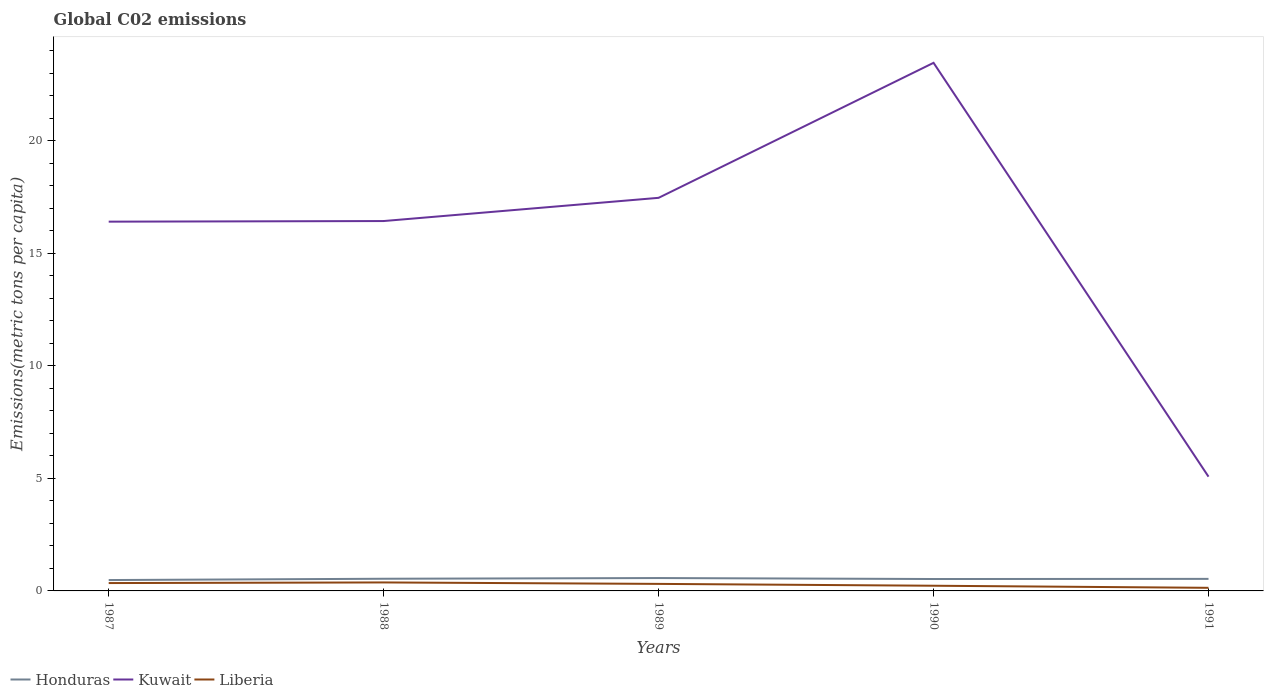How many different coloured lines are there?
Provide a short and direct response. 3. Does the line corresponding to Honduras intersect with the line corresponding to Liberia?
Provide a succinct answer. No. Is the number of lines equal to the number of legend labels?
Keep it short and to the point. Yes. Across all years, what is the maximum amount of CO2 emitted in in Honduras?
Give a very brief answer. 0.48. In which year was the amount of CO2 emitted in in Liberia maximum?
Ensure brevity in your answer.  1991. What is the total amount of CO2 emitted in in Liberia in the graph?
Offer a very short reply. 0.06. What is the difference between the highest and the second highest amount of CO2 emitted in in Liberia?
Offer a very short reply. 0.24. Is the amount of CO2 emitted in in Honduras strictly greater than the amount of CO2 emitted in in Liberia over the years?
Give a very brief answer. No. How many years are there in the graph?
Offer a terse response. 5. What is the difference between two consecutive major ticks on the Y-axis?
Keep it short and to the point. 5. Are the values on the major ticks of Y-axis written in scientific E-notation?
Your response must be concise. No. Does the graph contain grids?
Your answer should be compact. No. What is the title of the graph?
Offer a very short reply. Global C02 emissions. What is the label or title of the Y-axis?
Your answer should be compact. Emissions(metric tons per capita). What is the Emissions(metric tons per capita) of Honduras in 1987?
Give a very brief answer. 0.48. What is the Emissions(metric tons per capita) of Kuwait in 1987?
Your answer should be very brief. 16.41. What is the Emissions(metric tons per capita) of Liberia in 1987?
Provide a short and direct response. 0.35. What is the Emissions(metric tons per capita) in Honduras in 1988?
Offer a very short reply. 0.54. What is the Emissions(metric tons per capita) in Kuwait in 1988?
Your answer should be compact. 16.44. What is the Emissions(metric tons per capita) in Liberia in 1988?
Ensure brevity in your answer.  0.38. What is the Emissions(metric tons per capita) in Honduras in 1989?
Your answer should be compact. 0.57. What is the Emissions(metric tons per capita) in Kuwait in 1989?
Ensure brevity in your answer.  17.47. What is the Emissions(metric tons per capita) of Liberia in 1989?
Provide a short and direct response. 0.31. What is the Emissions(metric tons per capita) in Honduras in 1990?
Your response must be concise. 0.53. What is the Emissions(metric tons per capita) in Kuwait in 1990?
Make the answer very short. 23.47. What is the Emissions(metric tons per capita) of Liberia in 1990?
Make the answer very short. 0.23. What is the Emissions(metric tons per capita) in Honduras in 1991?
Provide a short and direct response. 0.54. What is the Emissions(metric tons per capita) of Kuwait in 1991?
Provide a short and direct response. 5.08. What is the Emissions(metric tons per capita) of Liberia in 1991?
Your response must be concise. 0.14. Across all years, what is the maximum Emissions(metric tons per capita) of Honduras?
Keep it short and to the point. 0.57. Across all years, what is the maximum Emissions(metric tons per capita) in Kuwait?
Your answer should be very brief. 23.47. Across all years, what is the maximum Emissions(metric tons per capita) of Liberia?
Your response must be concise. 0.38. Across all years, what is the minimum Emissions(metric tons per capita) of Honduras?
Provide a succinct answer. 0.48. Across all years, what is the minimum Emissions(metric tons per capita) of Kuwait?
Keep it short and to the point. 5.08. Across all years, what is the minimum Emissions(metric tons per capita) of Liberia?
Your answer should be compact. 0.14. What is the total Emissions(metric tons per capita) of Honduras in the graph?
Keep it short and to the point. 2.66. What is the total Emissions(metric tons per capita) in Kuwait in the graph?
Offer a terse response. 78.85. What is the total Emissions(metric tons per capita) of Liberia in the graph?
Your answer should be very brief. 1.41. What is the difference between the Emissions(metric tons per capita) in Honduras in 1987 and that in 1988?
Provide a short and direct response. -0.06. What is the difference between the Emissions(metric tons per capita) in Kuwait in 1987 and that in 1988?
Your answer should be very brief. -0.03. What is the difference between the Emissions(metric tons per capita) in Liberia in 1987 and that in 1988?
Provide a short and direct response. -0.03. What is the difference between the Emissions(metric tons per capita) of Honduras in 1987 and that in 1989?
Your answer should be very brief. -0.09. What is the difference between the Emissions(metric tons per capita) in Kuwait in 1987 and that in 1989?
Provide a short and direct response. -1.06. What is the difference between the Emissions(metric tons per capita) in Liberia in 1987 and that in 1989?
Provide a succinct answer. 0.04. What is the difference between the Emissions(metric tons per capita) of Honduras in 1987 and that in 1990?
Provide a succinct answer. -0.05. What is the difference between the Emissions(metric tons per capita) in Kuwait in 1987 and that in 1990?
Offer a very short reply. -7.06. What is the difference between the Emissions(metric tons per capita) of Liberia in 1987 and that in 1990?
Provide a succinct answer. 0.12. What is the difference between the Emissions(metric tons per capita) in Honduras in 1987 and that in 1991?
Provide a succinct answer. -0.05. What is the difference between the Emissions(metric tons per capita) in Kuwait in 1987 and that in 1991?
Give a very brief answer. 11.33. What is the difference between the Emissions(metric tons per capita) in Liberia in 1987 and that in 1991?
Provide a short and direct response. 0.21. What is the difference between the Emissions(metric tons per capita) in Honduras in 1988 and that in 1989?
Offer a terse response. -0.03. What is the difference between the Emissions(metric tons per capita) of Kuwait in 1988 and that in 1989?
Your answer should be very brief. -1.03. What is the difference between the Emissions(metric tons per capita) in Liberia in 1988 and that in 1989?
Ensure brevity in your answer.  0.06. What is the difference between the Emissions(metric tons per capita) in Honduras in 1988 and that in 1990?
Ensure brevity in your answer.  0.01. What is the difference between the Emissions(metric tons per capita) in Kuwait in 1988 and that in 1990?
Your answer should be very brief. -7.03. What is the difference between the Emissions(metric tons per capita) in Liberia in 1988 and that in 1990?
Provide a short and direct response. 0.15. What is the difference between the Emissions(metric tons per capita) of Honduras in 1988 and that in 1991?
Your response must be concise. 0.01. What is the difference between the Emissions(metric tons per capita) in Kuwait in 1988 and that in 1991?
Give a very brief answer. 11.36. What is the difference between the Emissions(metric tons per capita) of Liberia in 1988 and that in 1991?
Make the answer very short. 0.24. What is the difference between the Emissions(metric tons per capita) of Honduras in 1989 and that in 1990?
Provide a short and direct response. 0.04. What is the difference between the Emissions(metric tons per capita) in Kuwait in 1989 and that in 1990?
Provide a short and direct response. -6. What is the difference between the Emissions(metric tons per capita) of Liberia in 1989 and that in 1990?
Make the answer very short. 0.08. What is the difference between the Emissions(metric tons per capita) of Honduras in 1989 and that in 1991?
Provide a succinct answer. 0.04. What is the difference between the Emissions(metric tons per capita) in Kuwait in 1989 and that in 1991?
Provide a succinct answer. 12.39. What is the difference between the Emissions(metric tons per capita) of Liberia in 1989 and that in 1991?
Offer a very short reply. 0.17. What is the difference between the Emissions(metric tons per capita) in Honduras in 1990 and that in 1991?
Keep it short and to the point. -0.01. What is the difference between the Emissions(metric tons per capita) of Kuwait in 1990 and that in 1991?
Offer a very short reply. 18.39. What is the difference between the Emissions(metric tons per capita) in Liberia in 1990 and that in 1991?
Keep it short and to the point. 0.09. What is the difference between the Emissions(metric tons per capita) of Honduras in 1987 and the Emissions(metric tons per capita) of Kuwait in 1988?
Keep it short and to the point. -15.95. What is the difference between the Emissions(metric tons per capita) in Honduras in 1987 and the Emissions(metric tons per capita) in Liberia in 1988?
Ensure brevity in your answer.  0.11. What is the difference between the Emissions(metric tons per capita) in Kuwait in 1987 and the Emissions(metric tons per capita) in Liberia in 1988?
Give a very brief answer. 16.03. What is the difference between the Emissions(metric tons per capita) in Honduras in 1987 and the Emissions(metric tons per capita) in Kuwait in 1989?
Provide a succinct answer. -16.98. What is the difference between the Emissions(metric tons per capita) in Honduras in 1987 and the Emissions(metric tons per capita) in Liberia in 1989?
Offer a very short reply. 0.17. What is the difference between the Emissions(metric tons per capita) in Kuwait in 1987 and the Emissions(metric tons per capita) in Liberia in 1989?
Make the answer very short. 16.1. What is the difference between the Emissions(metric tons per capita) of Honduras in 1987 and the Emissions(metric tons per capita) of Kuwait in 1990?
Your answer should be compact. -22.98. What is the difference between the Emissions(metric tons per capita) in Honduras in 1987 and the Emissions(metric tons per capita) in Liberia in 1990?
Your response must be concise. 0.25. What is the difference between the Emissions(metric tons per capita) in Kuwait in 1987 and the Emissions(metric tons per capita) in Liberia in 1990?
Ensure brevity in your answer.  16.18. What is the difference between the Emissions(metric tons per capita) of Honduras in 1987 and the Emissions(metric tons per capita) of Kuwait in 1991?
Give a very brief answer. -4.59. What is the difference between the Emissions(metric tons per capita) in Honduras in 1987 and the Emissions(metric tons per capita) in Liberia in 1991?
Provide a succinct answer. 0.34. What is the difference between the Emissions(metric tons per capita) of Kuwait in 1987 and the Emissions(metric tons per capita) of Liberia in 1991?
Your response must be concise. 16.27. What is the difference between the Emissions(metric tons per capita) of Honduras in 1988 and the Emissions(metric tons per capita) of Kuwait in 1989?
Ensure brevity in your answer.  -16.93. What is the difference between the Emissions(metric tons per capita) of Honduras in 1988 and the Emissions(metric tons per capita) of Liberia in 1989?
Provide a short and direct response. 0.23. What is the difference between the Emissions(metric tons per capita) in Kuwait in 1988 and the Emissions(metric tons per capita) in Liberia in 1989?
Provide a short and direct response. 16.12. What is the difference between the Emissions(metric tons per capita) of Honduras in 1988 and the Emissions(metric tons per capita) of Kuwait in 1990?
Offer a very short reply. -22.93. What is the difference between the Emissions(metric tons per capita) of Honduras in 1988 and the Emissions(metric tons per capita) of Liberia in 1990?
Your response must be concise. 0.31. What is the difference between the Emissions(metric tons per capita) of Kuwait in 1988 and the Emissions(metric tons per capita) of Liberia in 1990?
Keep it short and to the point. 16.21. What is the difference between the Emissions(metric tons per capita) of Honduras in 1988 and the Emissions(metric tons per capita) of Kuwait in 1991?
Ensure brevity in your answer.  -4.54. What is the difference between the Emissions(metric tons per capita) of Honduras in 1988 and the Emissions(metric tons per capita) of Liberia in 1991?
Your response must be concise. 0.4. What is the difference between the Emissions(metric tons per capita) of Kuwait in 1988 and the Emissions(metric tons per capita) of Liberia in 1991?
Offer a very short reply. 16.3. What is the difference between the Emissions(metric tons per capita) of Honduras in 1989 and the Emissions(metric tons per capita) of Kuwait in 1990?
Keep it short and to the point. -22.89. What is the difference between the Emissions(metric tons per capita) in Honduras in 1989 and the Emissions(metric tons per capita) in Liberia in 1990?
Make the answer very short. 0.34. What is the difference between the Emissions(metric tons per capita) in Kuwait in 1989 and the Emissions(metric tons per capita) in Liberia in 1990?
Provide a succinct answer. 17.24. What is the difference between the Emissions(metric tons per capita) of Honduras in 1989 and the Emissions(metric tons per capita) of Kuwait in 1991?
Offer a very short reply. -4.5. What is the difference between the Emissions(metric tons per capita) in Honduras in 1989 and the Emissions(metric tons per capita) in Liberia in 1991?
Keep it short and to the point. 0.43. What is the difference between the Emissions(metric tons per capita) in Kuwait in 1989 and the Emissions(metric tons per capita) in Liberia in 1991?
Your answer should be very brief. 17.33. What is the difference between the Emissions(metric tons per capita) in Honduras in 1990 and the Emissions(metric tons per capita) in Kuwait in 1991?
Ensure brevity in your answer.  -4.55. What is the difference between the Emissions(metric tons per capita) of Honduras in 1990 and the Emissions(metric tons per capita) of Liberia in 1991?
Give a very brief answer. 0.39. What is the difference between the Emissions(metric tons per capita) in Kuwait in 1990 and the Emissions(metric tons per capita) in Liberia in 1991?
Provide a short and direct response. 23.33. What is the average Emissions(metric tons per capita) of Honduras per year?
Offer a terse response. 0.53. What is the average Emissions(metric tons per capita) of Kuwait per year?
Your answer should be very brief. 15.77. What is the average Emissions(metric tons per capita) in Liberia per year?
Give a very brief answer. 0.28. In the year 1987, what is the difference between the Emissions(metric tons per capita) in Honduras and Emissions(metric tons per capita) in Kuwait?
Your answer should be very brief. -15.92. In the year 1987, what is the difference between the Emissions(metric tons per capita) of Honduras and Emissions(metric tons per capita) of Liberia?
Keep it short and to the point. 0.13. In the year 1987, what is the difference between the Emissions(metric tons per capita) of Kuwait and Emissions(metric tons per capita) of Liberia?
Your answer should be compact. 16.06. In the year 1988, what is the difference between the Emissions(metric tons per capita) of Honduras and Emissions(metric tons per capita) of Kuwait?
Offer a very short reply. -15.89. In the year 1988, what is the difference between the Emissions(metric tons per capita) in Honduras and Emissions(metric tons per capita) in Liberia?
Give a very brief answer. 0.16. In the year 1988, what is the difference between the Emissions(metric tons per capita) in Kuwait and Emissions(metric tons per capita) in Liberia?
Your response must be concise. 16.06. In the year 1989, what is the difference between the Emissions(metric tons per capita) of Honduras and Emissions(metric tons per capita) of Kuwait?
Your answer should be compact. -16.89. In the year 1989, what is the difference between the Emissions(metric tons per capita) in Honduras and Emissions(metric tons per capita) in Liberia?
Provide a short and direct response. 0.26. In the year 1989, what is the difference between the Emissions(metric tons per capita) in Kuwait and Emissions(metric tons per capita) in Liberia?
Your answer should be compact. 17.15. In the year 1990, what is the difference between the Emissions(metric tons per capita) of Honduras and Emissions(metric tons per capita) of Kuwait?
Your answer should be compact. -22.94. In the year 1990, what is the difference between the Emissions(metric tons per capita) in Honduras and Emissions(metric tons per capita) in Liberia?
Your answer should be very brief. 0.3. In the year 1990, what is the difference between the Emissions(metric tons per capita) in Kuwait and Emissions(metric tons per capita) in Liberia?
Give a very brief answer. 23.24. In the year 1991, what is the difference between the Emissions(metric tons per capita) of Honduras and Emissions(metric tons per capita) of Kuwait?
Provide a short and direct response. -4.54. In the year 1991, what is the difference between the Emissions(metric tons per capita) of Honduras and Emissions(metric tons per capita) of Liberia?
Make the answer very short. 0.4. In the year 1991, what is the difference between the Emissions(metric tons per capita) in Kuwait and Emissions(metric tons per capita) in Liberia?
Provide a succinct answer. 4.94. What is the ratio of the Emissions(metric tons per capita) of Honduras in 1987 to that in 1988?
Your answer should be compact. 0.89. What is the ratio of the Emissions(metric tons per capita) of Kuwait in 1987 to that in 1988?
Ensure brevity in your answer.  1. What is the ratio of the Emissions(metric tons per capita) of Liberia in 1987 to that in 1988?
Your response must be concise. 0.93. What is the ratio of the Emissions(metric tons per capita) of Honduras in 1987 to that in 1989?
Keep it short and to the point. 0.84. What is the ratio of the Emissions(metric tons per capita) in Kuwait in 1987 to that in 1989?
Give a very brief answer. 0.94. What is the ratio of the Emissions(metric tons per capita) of Liberia in 1987 to that in 1989?
Offer a very short reply. 1.12. What is the ratio of the Emissions(metric tons per capita) of Honduras in 1987 to that in 1990?
Offer a very short reply. 0.91. What is the ratio of the Emissions(metric tons per capita) of Kuwait in 1987 to that in 1990?
Keep it short and to the point. 0.7. What is the ratio of the Emissions(metric tons per capita) of Liberia in 1987 to that in 1990?
Offer a terse response. 1.52. What is the ratio of the Emissions(metric tons per capita) in Honduras in 1987 to that in 1991?
Make the answer very short. 0.9. What is the ratio of the Emissions(metric tons per capita) of Kuwait in 1987 to that in 1991?
Give a very brief answer. 3.23. What is the ratio of the Emissions(metric tons per capita) in Liberia in 1987 to that in 1991?
Offer a very short reply. 2.52. What is the ratio of the Emissions(metric tons per capita) of Honduras in 1988 to that in 1989?
Your answer should be very brief. 0.94. What is the ratio of the Emissions(metric tons per capita) of Kuwait in 1988 to that in 1989?
Offer a very short reply. 0.94. What is the ratio of the Emissions(metric tons per capita) of Liberia in 1988 to that in 1989?
Keep it short and to the point. 1.21. What is the ratio of the Emissions(metric tons per capita) in Honduras in 1988 to that in 1990?
Offer a very short reply. 1.02. What is the ratio of the Emissions(metric tons per capita) in Kuwait in 1988 to that in 1990?
Keep it short and to the point. 0.7. What is the ratio of the Emissions(metric tons per capita) of Liberia in 1988 to that in 1990?
Your response must be concise. 1.64. What is the ratio of the Emissions(metric tons per capita) of Kuwait in 1988 to that in 1991?
Ensure brevity in your answer.  3.24. What is the ratio of the Emissions(metric tons per capita) in Liberia in 1988 to that in 1991?
Ensure brevity in your answer.  2.72. What is the ratio of the Emissions(metric tons per capita) of Honduras in 1989 to that in 1990?
Offer a terse response. 1.08. What is the ratio of the Emissions(metric tons per capita) in Kuwait in 1989 to that in 1990?
Offer a very short reply. 0.74. What is the ratio of the Emissions(metric tons per capita) in Liberia in 1989 to that in 1990?
Provide a short and direct response. 1.36. What is the ratio of the Emissions(metric tons per capita) in Honduras in 1989 to that in 1991?
Provide a short and direct response. 1.07. What is the ratio of the Emissions(metric tons per capita) of Kuwait in 1989 to that in 1991?
Your response must be concise. 3.44. What is the ratio of the Emissions(metric tons per capita) in Liberia in 1989 to that in 1991?
Give a very brief answer. 2.26. What is the ratio of the Emissions(metric tons per capita) in Honduras in 1990 to that in 1991?
Keep it short and to the point. 0.99. What is the ratio of the Emissions(metric tons per capita) in Kuwait in 1990 to that in 1991?
Your answer should be compact. 4.62. What is the ratio of the Emissions(metric tons per capita) in Liberia in 1990 to that in 1991?
Ensure brevity in your answer.  1.66. What is the difference between the highest and the second highest Emissions(metric tons per capita) in Honduras?
Provide a succinct answer. 0.03. What is the difference between the highest and the second highest Emissions(metric tons per capita) of Kuwait?
Offer a terse response. 6. What is the difference between the highest and the second highest Emissions(metric tons per capita) in Liberia?
Give a very brief answer. 0.03. What is the difference between the highest and the lowest Emissions(metric tons per capita) in Honduras?
Offer a very short reply. 0.09. What is the difference between the highest and the lowest Emissions(metric tons per capita) of Kuwait?
Provide a short and direct response. 18.39. What is the difference between the highest and the lowest Emissions(metric tons per capita) in Liberia?
Provide a short and direct response. 0.24. 